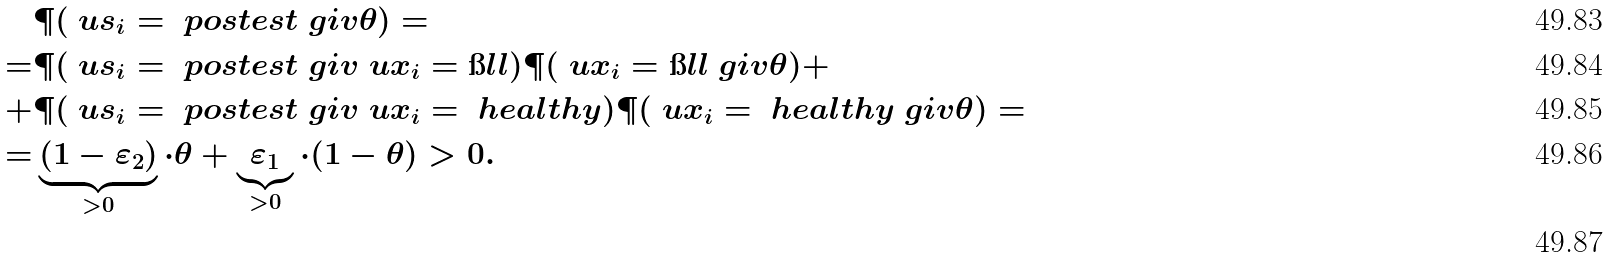<formula> <loc_0><loc_0><loc_500><loc_500>& \P ( \ u s _ { i } = \ p o s t e s t \ g i v \theta ) = \\ = & \P ( \ u s _ { i } = \ p o s t e s t \ g i v \ u x _ { i } = \i l l ) \P ( \ u x _ { i } = \i l l \ g i v \theta ) + \\ + & \P ( \ u s _ { i } = \ p o s t e s t \ g i v \ u x _ { i } = \ h e a l t h y ) \P ( \ u x _ { i } = \ h e a l t h y \ g i v \theta ) = \\ = & \underbrace { ( 1 - \varepsilon _ { 2 } ) } _ { > 0 } \cdot \theta + \underbrace { \varepsilon _ { 1 } } _ { > 0 } \cdot ( 1 - \theta ) > 0 . \\</formula> 